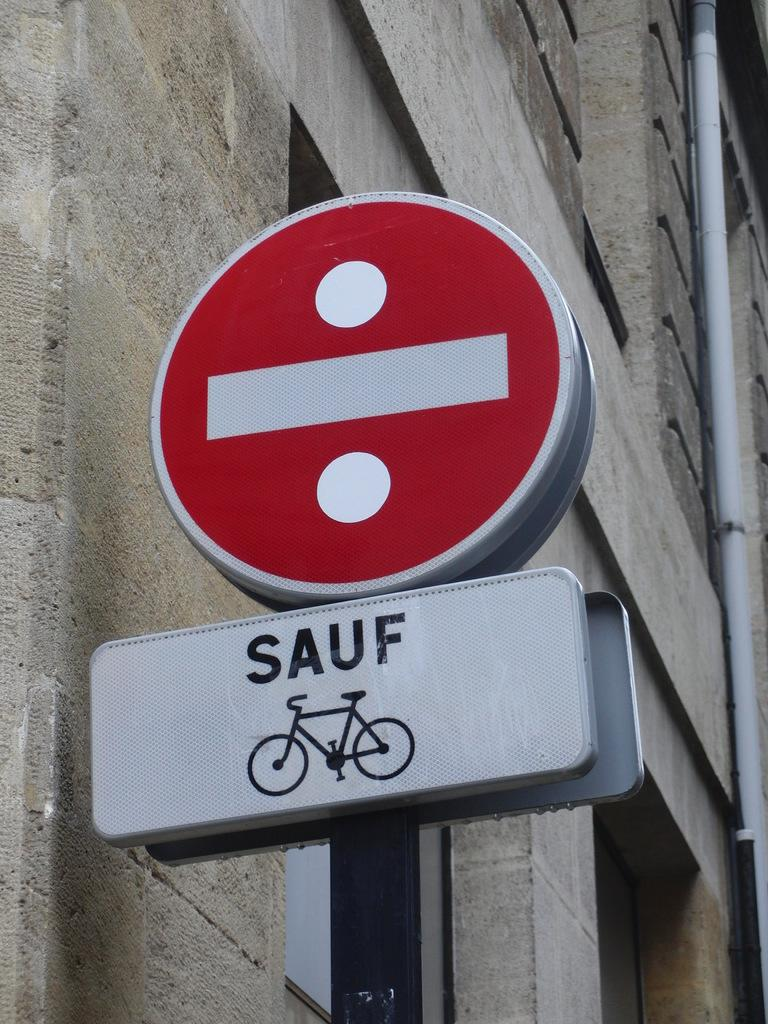<image>
Provide a brief description of the given image. The international sign for 'do not enter' has a sign just below it with the word 'sauf' and an image of a bicycle. 